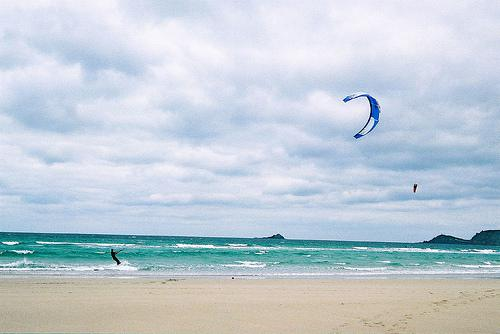Question: what color is the sand?
Choices:
A. Yellow.
B. Gray.
C. White.
D. Tan.
Answer with the letter. Answer: A Question: where is this shot?
Choices:
A. Park.
B. Pasture.
C. Field.
D. Beach.
Answer with the letter. Answer: D 